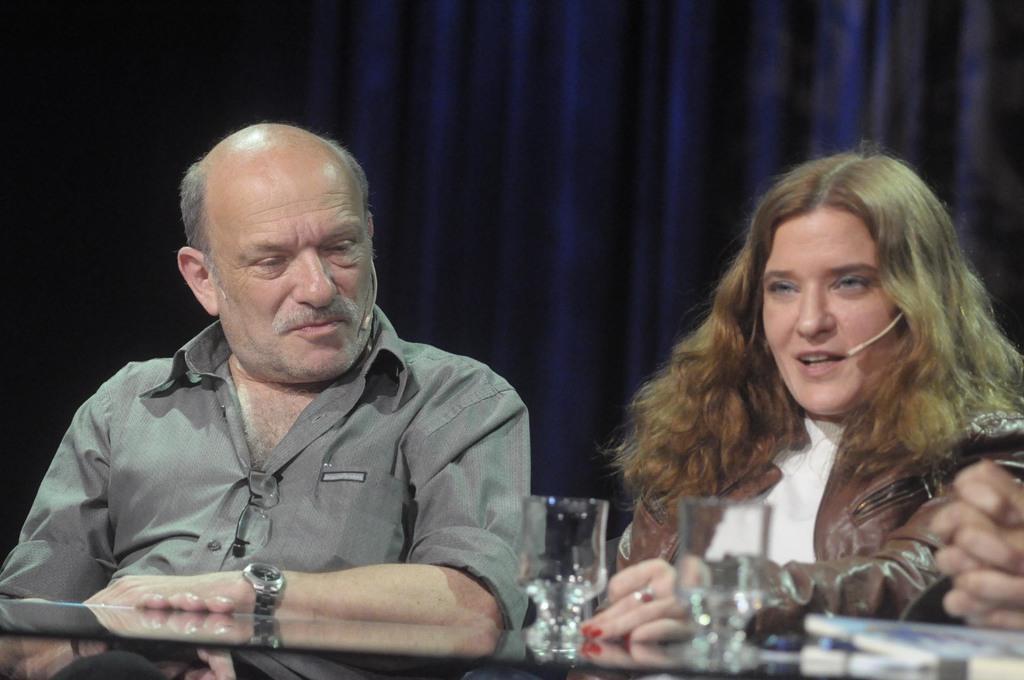Can you describe this image briefly? In this image we can see man and woman sitting at the table. On the table we can see glass tumblers. In the background there is curtain. 